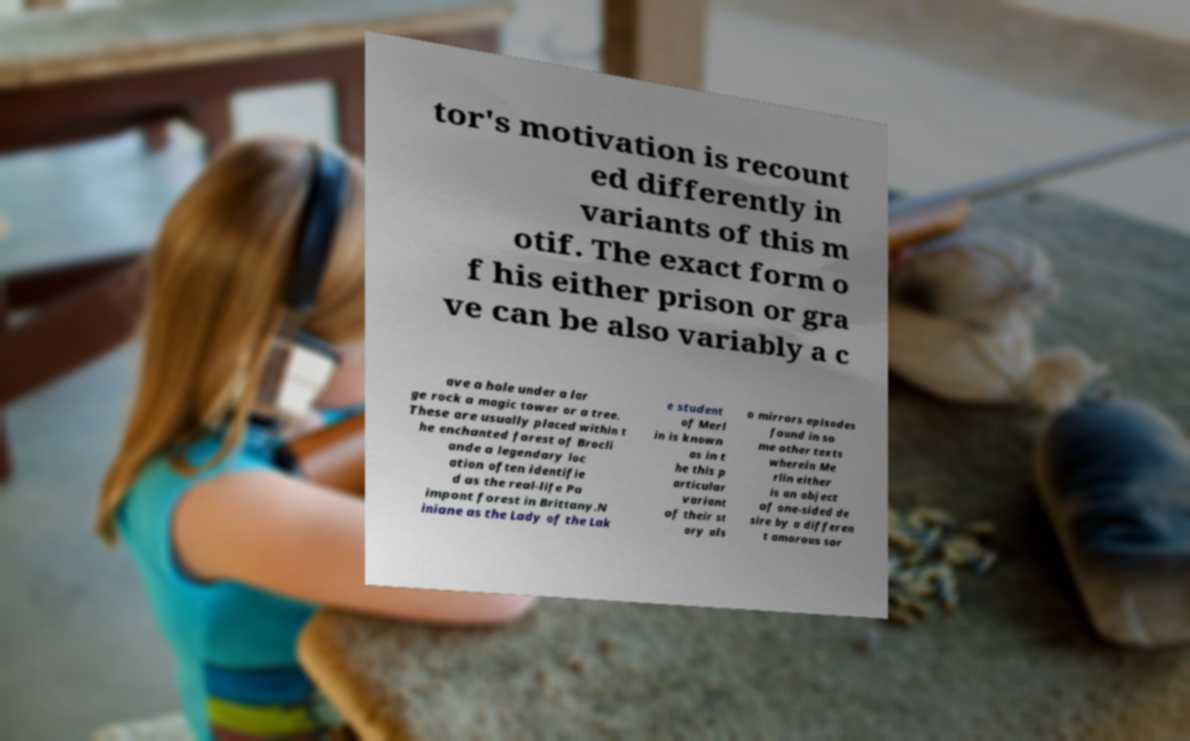Could you assist in decoding the text presented in this image and type it out clearly? tor's motivation is recount ed differently in variants of this m otif. The exact form o f his either prison or gra ve can be also variably a c ave a hole under a lar ge rock a magic tower or a tree. These are usually placed within t he enchanted forest of Brocli ande a legendary loc ation often identifie d as the real-life Pa impont forest in Brittany.N iniane as the Lady of the Lak e student of Merl in is known as in t he this p articular variant of their st ory als o mirrors episodes found in so me other texts wherein Me rlin either is an object of one-sided de sire by a differen t amorous sor 